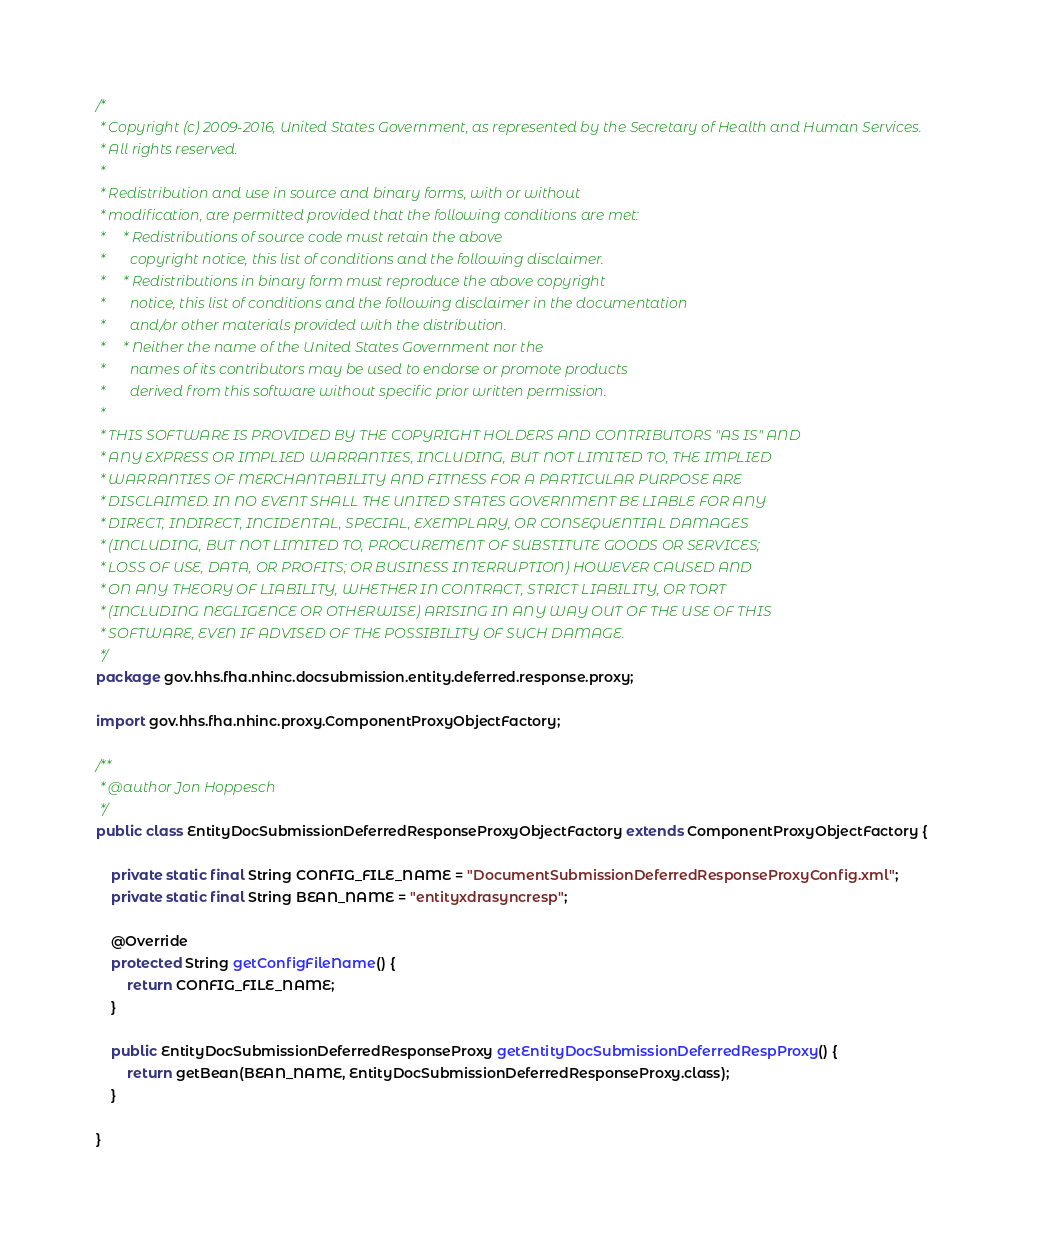Convert code to text. <code><loc_0><loc_0><loc_500><loc_500><_Java_>/*
 * Copyright (c) 2009-2016, United States Government, as represented by the Secretary of Health and Human Services.
 * All rights reserved.
 *
 * Redistribution and use in source and binary forms, with or without
 * modification, are permitted provided that the following conditions are met:
 *     * Redistributions of source code must retain the above
 *       copyright notice, this list of conditions and the following disclaimer.
 *     * Redistributions in binary form must reproduce the above copyright
 *       notice, this list of conditions and the following disclaimer in the documentation
 *       and/or other materials provided with the distribution.
 *     * Neither the name of the United States Government nor the
 *       names of its contributors may be used to endorse or promote products
 *       derived from this software without specific prior written permission.
 *
 * THIS SOFTWARE IS PROVIDED BY THE COPYRIGHT HOLDERS AND CONTRIBUTORS "AS IS" AND
 * ANY EXPRESS OR IMPLIED WARRANTIES, INCLUDING, BUT NOT LIMITED TO, THE IMPLIED
 * WARRANTIES OF MERCHANTABILITY AND FITNESS FOR A PARTICULAR PURPOSE ARE
 * DISCLAIMED. IN NO EVENT SHALL THE UNITED STATES GOVERNMENT BE LIABLE FOR ANY
 * DIRECT, INDIRECT, INCIDENTAL, SPECIAL, EXEMPLARY, OR CONSEQUENTIAL DAMAGES
 * (INCLUDING, BUT NOT LIMITED TO, PROCUREMENT OF SUBSTITUTE GOODS OR SERVICES;
 * LOSS OF USE, DATA, OR PROFITS; OR BUSINESS INTERRUPTION) HOWEVER CAUSED AND
 * ON ANY THEORY OF LIABILITY, WHETHER IN CONTRACT, STRICT LIABILITY, OR TORT
 * (INCLUDING NEGLIGENCE OR OTHERWISE) ARISING IN ANY WAY OUT OF THE USE OF THIS
 * SOFTWARE, EVEN IF ADVISED OF THE POSSIBILITY OF SUCH DAMAGE.
 */
package gov.hhs.fha.nhinc.docsubmission.entity.deferred.response.proxy;

import gov.hhs.fha.nhinc.proxy.ComponentProxyObjectFactory;

/**
 * @author Jon Hoppesch
 */
public class EntityDocSubmissionDeferredResponseProxyObjectFactory extends ComponentProxyObjectFactory {

    private static final String CONFIG_FILE_NAME = "DocumentSubmissionDeferredResponseProxyConfig.xml";
    private static final String BEAN_NAME = "entityxdrasyncresp";

    @Override
    protected String getConfigFileName() {
        return CONFIG_FILE_NAME;
    }

    public EntityDocSubmissionDeferredResponseProxy getEntityDocSubmissionDeferredRespProxy() {
        return getBean(BEAN_NAME, EntityDocSubmissionDeferredResponseProxy.class);
    }

}
</code> 